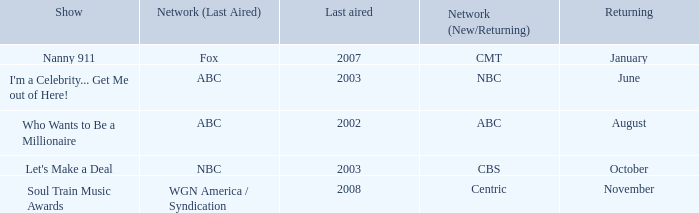When did soul train music awards return? November. 